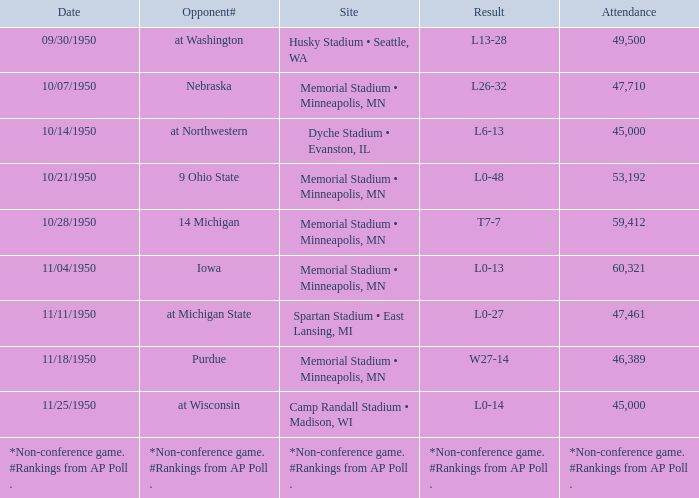What is the Attendance when the Result is l0-13? 60321.0. 